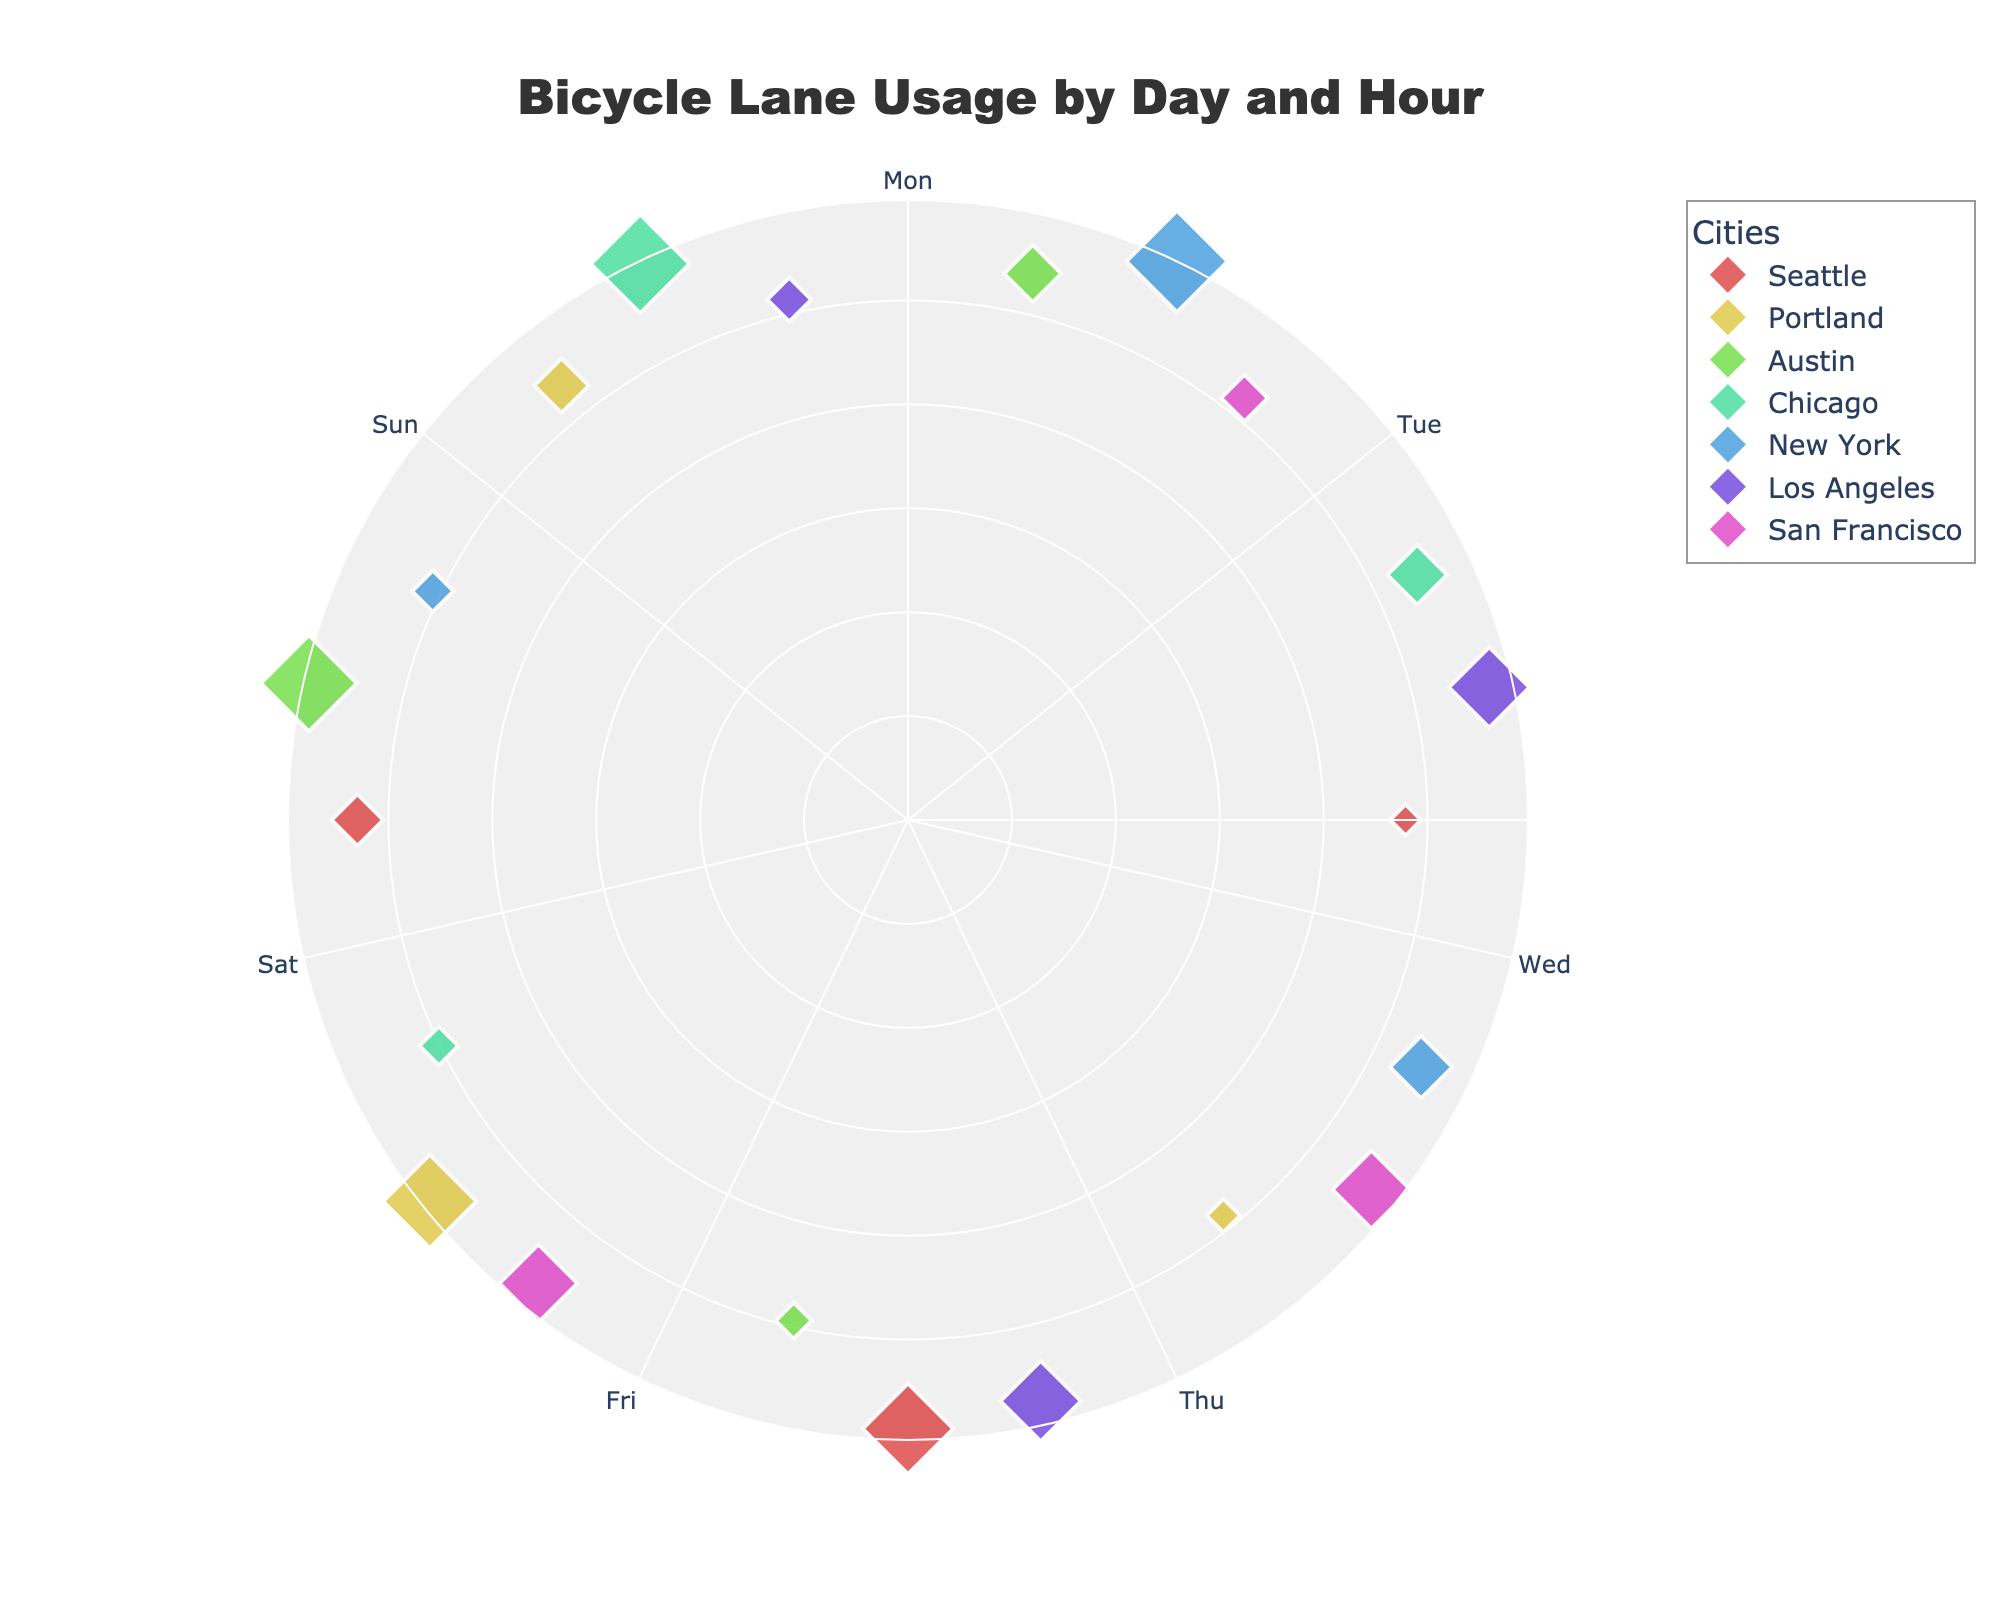What's the title of the figure? The title is prominently displayed at the top of the figure in a larger font size.
Answer: Bicycle Lane Usage by Day and Hour What are the radial axis units? The radial axis, represented by circles, ranges visually based on the radius values, which are derived from the logarithms of the number of bicycle lanes used.
Answer: Log-scaled bicycle lanes used Which city has the highest marker size on Friday at 12:00? Look for the largest marker size at the point corresponding to Friday at 12:00. Here, New York's marker is the largest, indicating the highest bicycle lane usage.
Answer: New York How many different cities are represented in the chart? Count the number of different city names in the legend or among the data points.
Answer: 7 What's the color of markers representing San Francisco? Identify the color corresponding to San Francisco in the legend.
Answer: Light Blue On which day and hour does Los Angeles have equal bicycle lane usage compared to Sunday at 18:00? Check Los Angeles' data points against Sunday's 18:00 data point for equal usage, both at 310 bike counts. This is observed on Saturday at 12:00 and 18:00 as well.
Answer: Saturday at 12:00 and 18:00 What is the comparative usage pattern between weekdays and weekends? Compare the marker sizes and positions for Saturday and Sunday with those from Monday to Friday. Weekdays generally have higher usage in the middle of the day.
Answer: Higher weekday usage Which city shows the least change in bicycle lane usage across different hours on the same day? Look for a city whose marker sizes are more consistent across the different hours on the same day. Los Angeles shows little variation.
Answer: Los Angeles Which day of the week exhibits the highest bicycle lane usage at 6:00 AM? Identify the largest marker size among all cities at 6:00 AM for different days.
Answer: Sunday Comparing Austin and Chicago, which one has a higher bicycle lane usage on Thursday at 18:00? Review the marker sizes for Austin and Chicago at the point representing Thursday at 18:00; Chicago has a larger marker at that specific time.
Answer: Chicago 